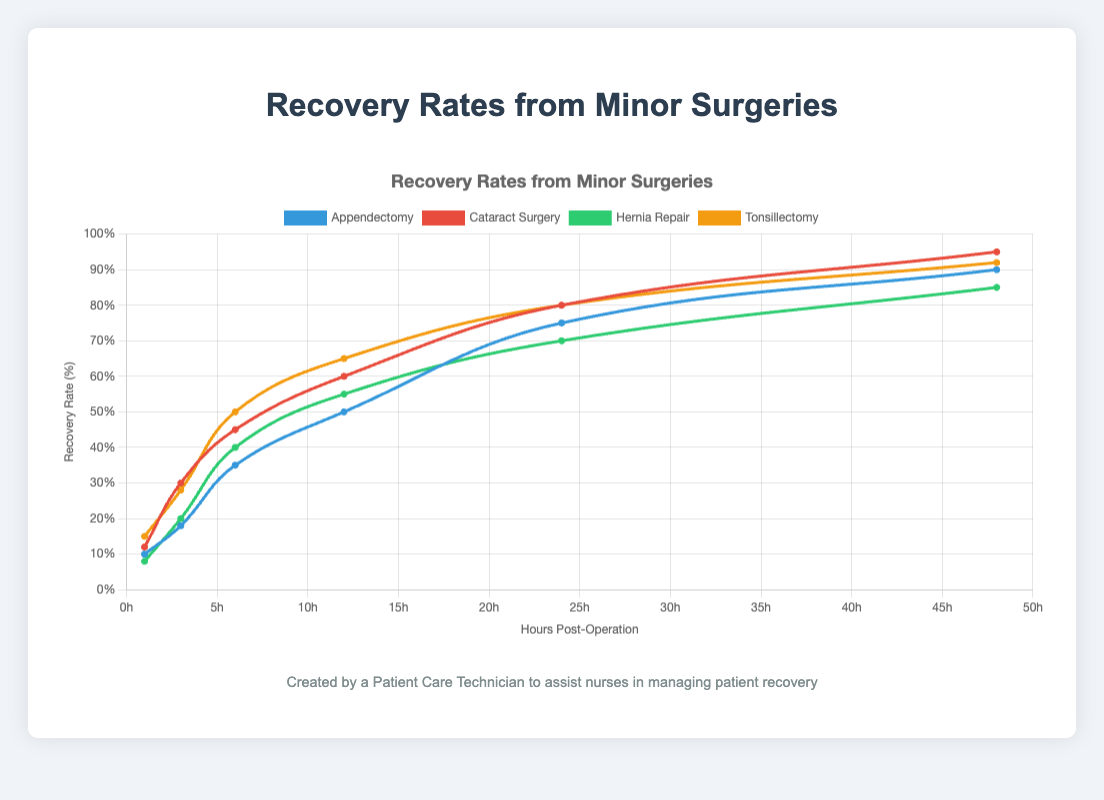What is the recovery rate for Cataract Surgery 6 hours post-operation? From the chart, locate the curve labeled "Cataract Surgery" and find the data point at 6 hours post-operation. The recovery rate at this point is indicated as 45%.
Answer: 45% Which type of surgery has the highest recovery rate 48 hours post-operation? Examine the chart and compare the recovery rates at 48 hours post-operation for all surgeries. Cataract Surgery has the highest recovery rate at 95%.
Answer: Cataract Surgery What is the difference in recovery rates between Hernia Repair and Tonsillectomy 24 hours post-operation? Locate the recovery rates for Hernia Repair and Tonsillectomy at 24 hours post-operation. Hernia Repair has a recovery rate of 70%, while Tonsillectomy has a recovery rate of 80%. The difference is 80% - 70% = 10%.
Answer: 10% Which surgery has the fastest recovery in the first 12 hours post-operation? Observe the slope of each curve within the first 12 hours post-operation. Cataract Surgery and Tonsillectomy both show a significant initial recovery rate, but Cataract Surgery has a higher overall rate within 12 hours, reaching 60%.
Answer: Cataract Surgery What is the average recovery rate at 6 hours post-operation across all surgeries? Find the recovery rates for each surgery at 6 hours post-operation: Appendectomy (35%), Cataract Surgery (45%), Hernia Repair (40%), Tonsillectomy (50%). Calculate the average as (35 + 45 + 40 + 50) / 4 = 170 / 4 = 42.5%.
Answer: 42.5% How does the recovery rate for Hernia Repair compare to Appendectomy 3 hours post-operation? Compare the recovery rates for Hernia Repair (20%) and Appendectomy (18%) at 3 hours post-operation. The recovery rate for Hernia Repair is slightly higher by 2%.
Answer: Hernia Repair is higher by 2% What is the visual difference between the recovery rates of Appendectomy and Tonsillectomy at 48 hours post-operation? Observe the two curves at the 48-hour mark. Appendectomy's curve reaches 90%, whereas Tonsillectomy's curve reaches 92%, showing that Tonsillectomy has a marginally higher recovery rate.
Answer: Tonsillectomy is higher by 2% Which surgery shows the steepest increase in recovery rate between 1 and 6 hours post-operation? Compare the steepness of the curves (rate of change) between 1 and 6 hours. Tonsillectomy shows the steepest increase as it reaches 50% from 15%, a difference of 35%, among the surgeries.
Answer: Tonsillectomy 